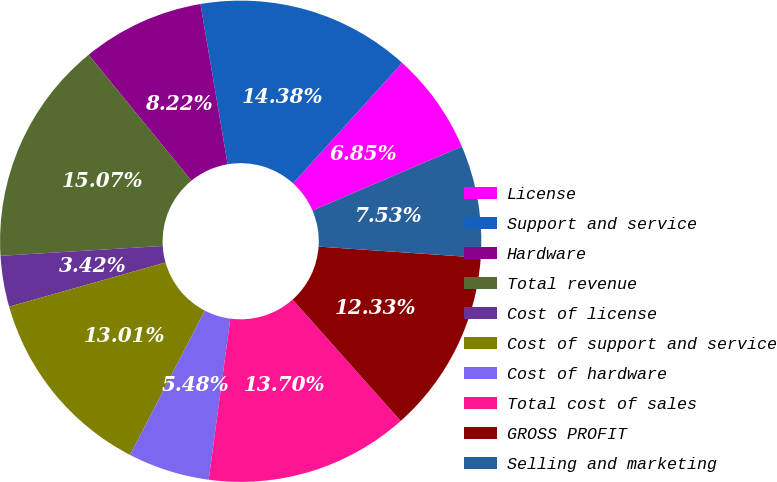Convert chart to OTSL. <chart><loc_0><loc_0><loc_500><loc_500><pie_chart><fcel>License<fcel>Support and service<fcel>Hardware<fcel>Total revenue<fcel>Cost of license<fcel>Cost of support and service<fcel>Cost of hardware<fcel>Total cost of sales<fcel>GROSS PROFIT<fcel>Selling and marketing<nl><fcel>6.85%<fcel>14.38%<fcel>8.22%<fcel>15.07%<fcel>3.42%<fcel>13.01%<fcel>5.48%<fcel>13.7%<fcel>12.33%<fcel>7.53%<nl></chart> 